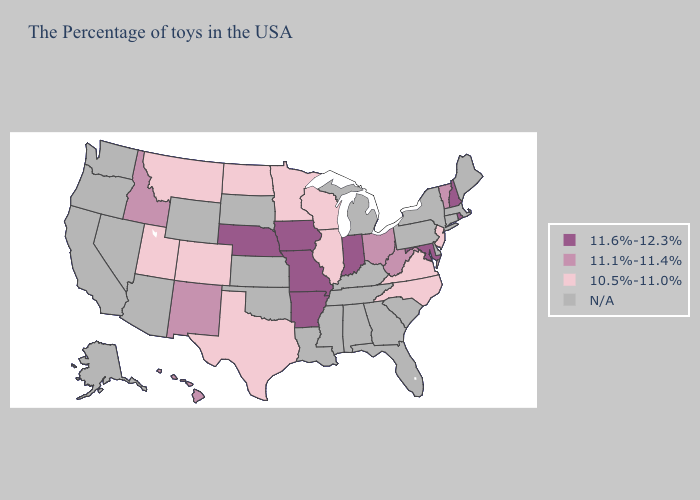Does North Dakota have the lowest value in the USA?
Write a very short answer. Yes. What is the highest value in the USA?
Concise answer only. 11.6%-12.3%. Which states have the highest value in the USA?
Be succinct. Rhode Island, New Hampshire, Maryland, Indiana, Missouri, Arkansas, Iowa, Nebraska. Does New Jersey have the lowest value in the Northeast?
Answer briefly. Yes. Name the states that have a value in the range 11.6%-12.3%?
Quick response, please. Rhode Island, New Hampshire, Maryland, Indiana, Missouri, Arkansas, Iowa, Nebraska. Which states have the lowest value in the West?
Short answer required. Colorado, Utah, Montana. Which states have the lowest value in the South?
Write a very short answer. Virginia, North Carolina, Texas. Does Colorado have the highest value in the USA?
Be succinct. No. What is the lowest value in the South?
Short answer required. 10.5%-11.0%. Which states have the lowest value in the USA?
Give a very brief answer. New Jersey, Virginia, North Carolina, Wisconsin, Illinois, Minnesota, Texas, North Dakota, Colorado, Utah, Montana. What is the lowest value in the USA?
Answer briefly. 10.5%-11.0%. Name the states that have a value in the range 11.1%-11.4%?
Quick response, please. Vermont, West Virginia, Ohio, New Mexico, Idaho, Hawaii. Among the states that border Colorado , which have the lowest value?
Write a very short answer. Utah. How many symbols are there in the legend?
Short answer required. 4. What is the highest value in states that border West Virginia?
Answer briefly. 11.6%-12.3%. 